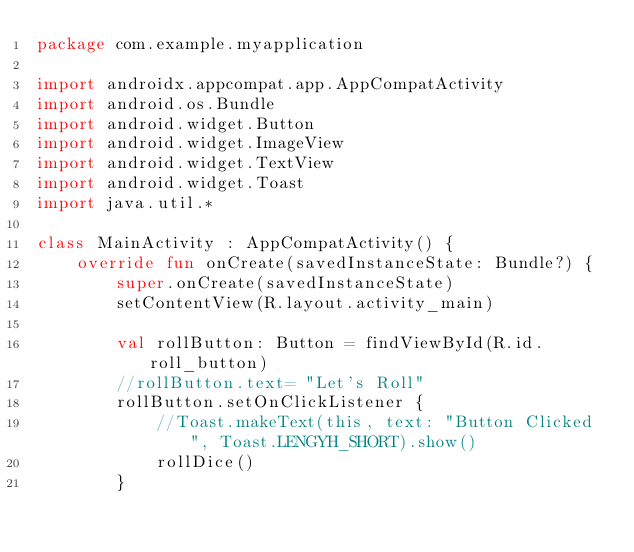<code> <loc_0><loc_0><loc_500><loc_500><_Kotlin_>package com.example.myapplication

import androidx.appcompat.app.AppCompatActivity
import android.os.Bundle
import android.widget.Button
import android.widget.ImageView
import android.widget.TextView
import android.widget.Toast
import java.util.*

class MainActivity : AppCompatActivity() {
    override fun onCreate(savedInstanceState: Bundle?) {
        super.onCreate(savedInstanceState)
        setContentView(R.layout.activity_main)

        val rollButton: Button = findViewById(R.id.roll_button)
        //rollButton.text= "Let's Roll"
        rollButton.setOnClickListener {
            //Toast.makeText(this, text: "Button Clicked", Toast.LENGYH_SHORT).show()
            rollDice()
        }</code> 